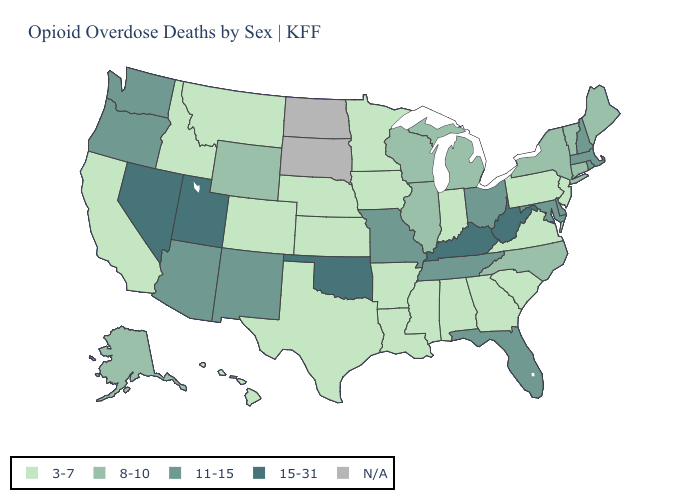Name the states that have a value in the range N/A?
Quick response, please. North Dakota, South Dakota. Which states hav the highest value in the Northeast?
Keep it brief. Massachusetts, New Hampshire, Rhode Island. Name the states that have a value in the range 8-10?
Keep it brief. Alaska, Connecticut, Illinois, Maine, Michigan, New York, North Carolina, Vermont, Wisconsin, Wyoming. Name the states that have a value in the range 15-31?
Give a very brief answer. Kentucky, Nevada, Oklahoma, Utah, West Virginia. Name the states that have a value in the range N/A?
Write a very short answer. North Dakota, South Dakota. Which states have the lowest value in the USA?
Keep it brief. Alabama, Arkansas, California, Colorado, Georgia, Hawaii, Idaho, Indiana, Iowa, Kansas, Louisiana, Minnesota, Mississippi, Montana, Nebraska, New Jersey, Pennsylvania, South Carolina, Texas, Virginia. Does Wyoming have the lowest value in the West?
Short answer required. No. What is the value of Colorado?
Concise answer only. 3-7. What is the value of South Dakota?
Quick response, please. N/A. What is the value of Utah?
Keep it brief. 15-31. Name the states that have a value in the range 11-15?
Give a very brief answer. Arizona, Delaware, Florida, Maryland, Massachusetts, Missouri, New Hampshire, New Mexico, Ohio, Oregon, Rhode Island, Tennessee, Washington. What is the highest value in the West ?
Answer briefly. 15-31. Name the states that have a value in the range 11-15?
Give a very brief answer. Arizona, Delaware, Florida, Maryland, Massachusetts, Missouri, New Hampshire, New Mexico, Ohio, Oregon, Rhode Island, Tennessee, Washington. 